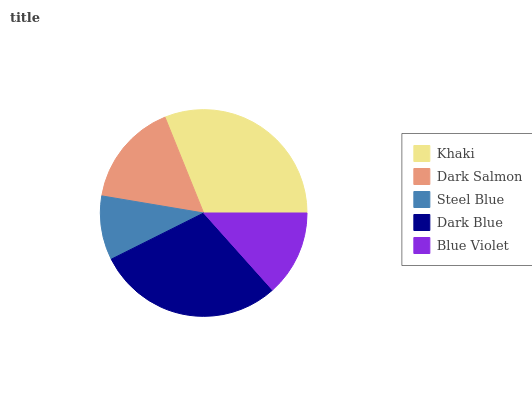Is Steel Blue the minimum?
Answer yes or no. Yes. Is Khaki the maximum?
Answer yes or no. Yes. Is Dark Salmon the minimum?
Answer yes or no. No. Is Dark Salmon the maximum?
Answer yes or no. No. Is Khaki greater than Dark Salmon?
Answer yes or no. Yes. Is Dark Salmon less than Khaki?
Answer yes or no. Yes. Is Dark Salmon greater than Khaki?
Answer yes or no. No. Is Khaki less than Dark Salmon?
Answer yes or no. No. Is Dark Salmon the high median?
Answer yes or no. Yes. Is Dark Salmon the low median?
Answer yes or no. Yes. Is Dark Blue the high median?
Answer yes or no. No. Is Khaki the low median?
Answer yes or no. No. 